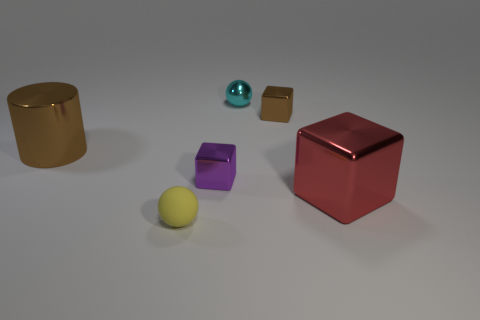What number of blocks are big things or blue objects?
Keep it short and to the point. 1. How many small spheres are both in front of the red metal block and right of the small yellow sphere?
Give a very brief answer. 0. What color is the sphere that is to the right of the yellow thing?
Make the answer very short. Cyan. There is a purple block that is the same material as the small brown object; what is its size?
Offer a very short reply. Small. There is a brown shiny object left of the tiny metallic sphere; what number of cubes are in front of it?
Provide a succinct answer. 2. What number of tiny purple shiny objects are behind the tiny yellow rubber object?
Provide a succinct answer. 1. What color is the tiny thing in front of the tiny metallic block that is on the left side of the brown cube behind the big shiny cylinder?
Offer a very short reply. Yellow. There is a large object that is to the left of the red metal object; is its color the same as the small block behind the tiny purple cube?
Offer a very short reply. Yes. What shape is the large shiny object that is on the right side of the ball that is in front of the large brown cylinder?
Make the answer very short. Cube. Is there a brown metallic object of the same size as the red object?
Ensure brevity in your answer.  Yes. 